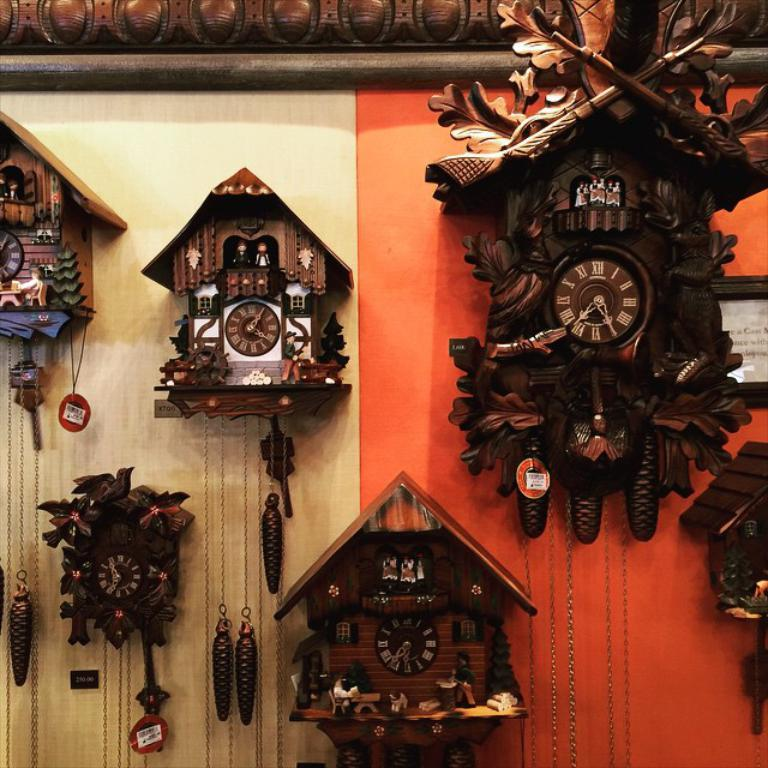<image>
Relay a brief, clear account of the picture shown. A collection of cuckoo clocks, of which the top right one says that it is 7:30. 